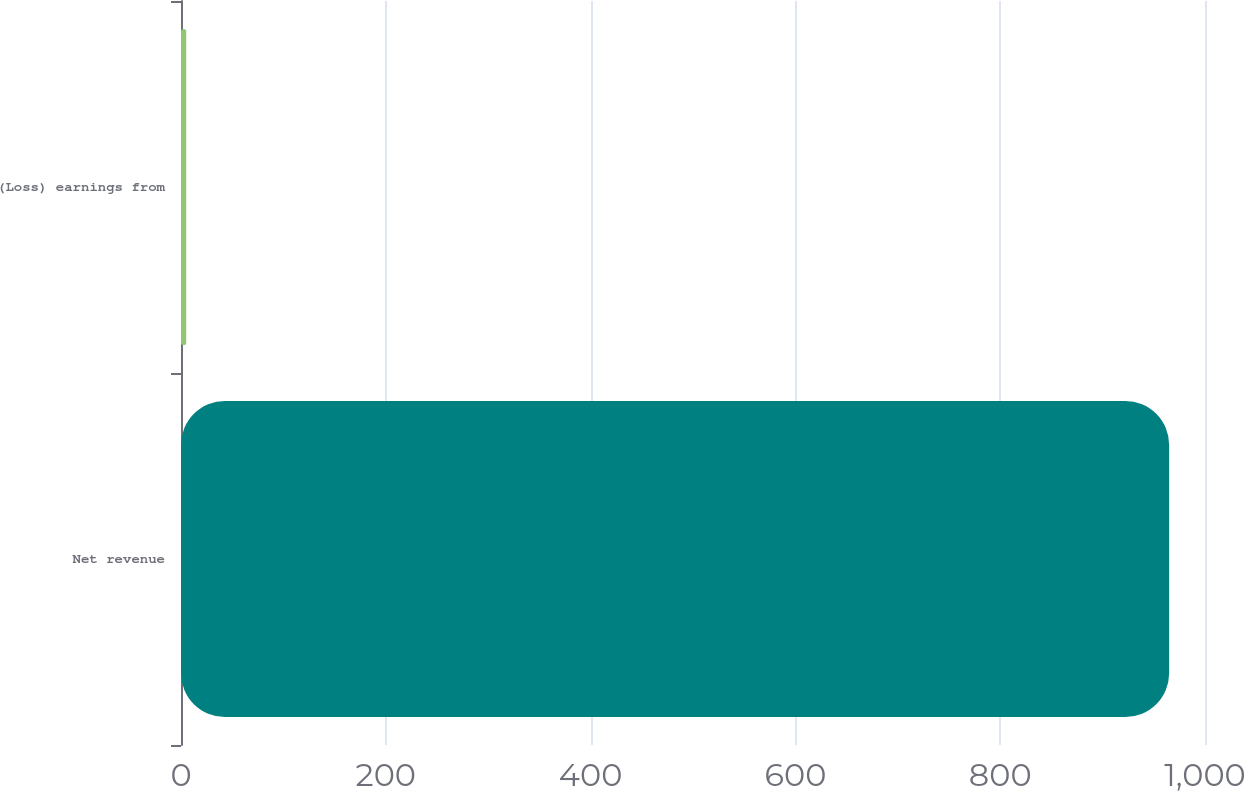Convert chart to OTSL. <chart><loc_0><loc_0><loc_500><loc_500><bar_chart><fcel>Net revenue<fcel>(Loss) earnings from<nl><fcel>965<fcel>5.1<nl></chart> 